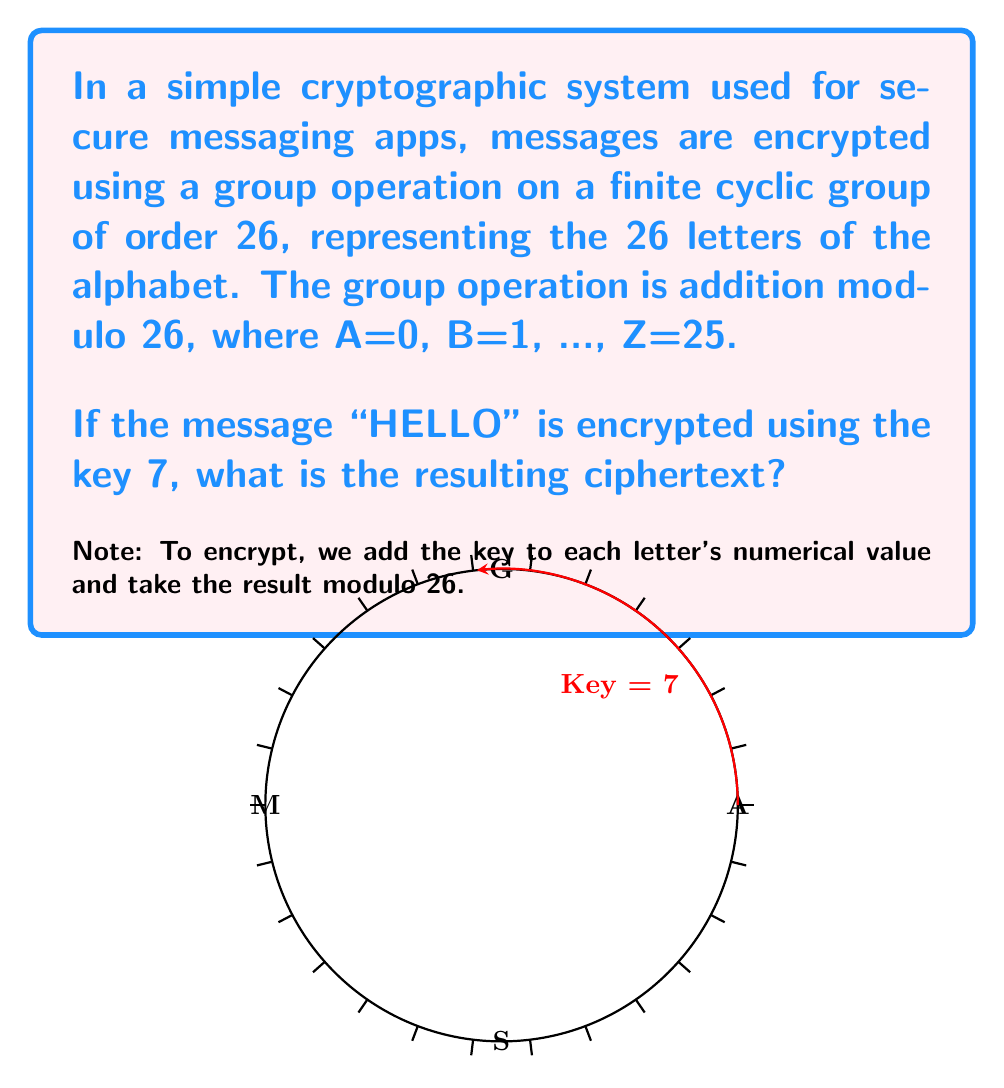Provide a solution to this math problem. Let's approach this step-by-step:

1) First, we need to convert each letter of "HELLO" to its numerical equivalent:
   H = 7, E = 4, L = 11, L = 11, O = 14

2) Now, we add the key (7) to each number and take the result modulo 26:

   For H: $(7 + 7) \mod 26 = 14 \mod 26 = 14$
   For E: $(4 + 7) \mod 26 = 11 \mod 26 = 11$
   For L: $(11 + 7) \mod 26 = 18 \mod 26 = 18$
   For L: $(11 + 7) \mod 26 = 18 \mod 26 = 18$
   For O: $(14 + 7) \mod 26 = 21 \mod 26 = 21$

3) Finally, we convert these numbers back to letters:
   14 = O, 11 = L, 18 = S, 18 = S, 21 = V

Therefore, the encrypted message is "OLSSV".

This encryption method is an example of the Caesar cipher, which is a simple application of group theory in cryptography. The set of 26 letters forms a cyclic group under addition modulo 26, and the encryption key acts as a group element that "shifts" each letter by a fixed amount.
Answer: OLSSV 